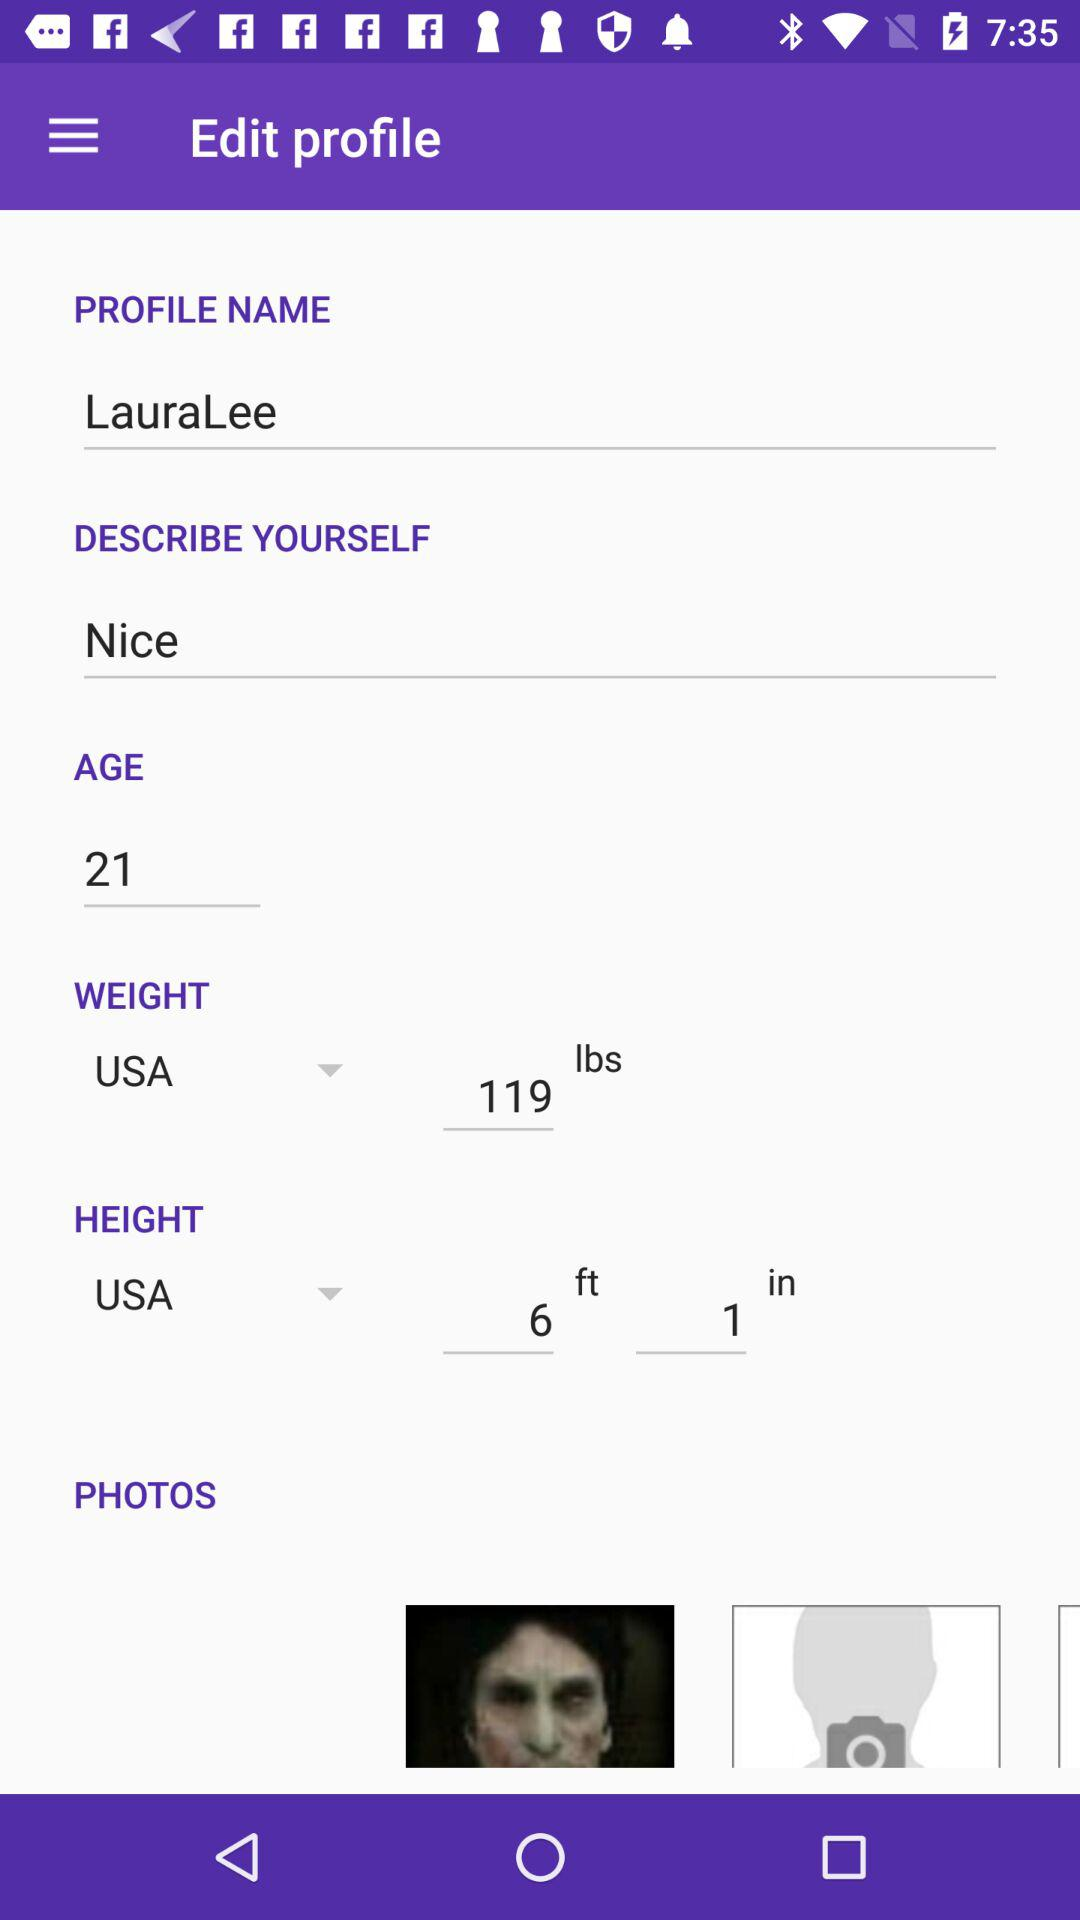What is written in "DESCRIBE YOURSELF"? In "DESCRIBE YOURSELF", "Nice" is written. 